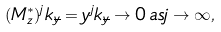<formula> <loc_0><loc_0><loc_500><loc_500>( M _ { z } ^ { * } ) ^ { j } k _ { \overline { y } } = y ^ { j } k _ { \overline { y } } \rightarrow 0 \, a s j \rightarrow \infty ,</formula> 